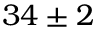<formula> <loc_0><loc_0><loc_500><loc_500>3 4 \pm 2</formula> 